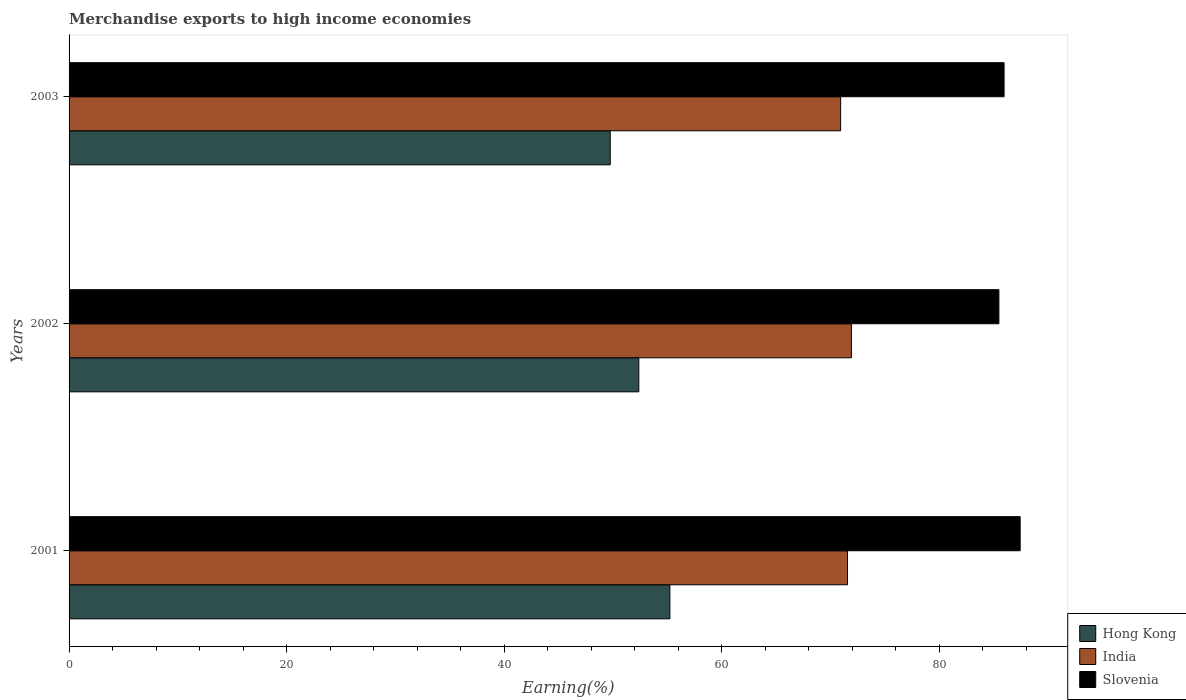Are the number of bars per tick equal to the number of legend labels?
Keep it short and to the point. Yes. How many bars are there on the 2nd tick from the top?
Your response must be concise. 3. What is the percentage of amount earned from merchandise exports in Hong Kong in 2003?
Offer a very short reply. 49.76. Across all years, what is the maximum percentage of amount earned from merchandise exports in India?
Keep it short and to the point. 71.94. Across all years, what is the minimum percentage of amount earned from merchandise exports in India?
Your answer should be compact. 70.95. In which year was the percentage of amount earned from merchandise exports in Slovenia minimum?
Keep it short and to the point. 2002. What is the total percentage of amount earned from merchandise exports in Hong Kong in the graph?
Give a very brief answer. 157.39. What is the difference between the percentage of amount earned from merchandise exports in Hong Kong in 2001 and that in 2003?
Offer a terse response. 5.49. What is the difference between the percentage of amount earned from merchandise exports in Slovenia in 2001 and the percentage of amount earned from merchandise exports in India in 2003?
Your answer should be compact. 16.51. What is the average percentage of amount earned from merchandise exports in Hong Kong per year?
Provide a short and direct response. 52.46. In the year 2002, what is the difference between the percentage of amount earned from merchandise exports in Slovenia and percentage of amount earned from merchandise exports in India?
Offer a terse response. 13.56. In how many years, is the percentage of amount earned from merchandise exports in Hong Kong greater than 72 %?
Give a very brief answer. 0. What is the ratio of the percentage of amount earned from merchandise exports in Slovenia in 2001 to that in 2003?
Your answer should be compact. 1.02. Is the percentage of amount earned from merchandise exports in Hong Kong in 2001 less than that in 2002?
Offer a terse response. No. What is the difference between the highest and the second highest percentage of amount earned from merchandise exports in India?
Offer a very short reply. 0.36. What is the difference between the highest and the lowest percentage of amount earned from merchandise exports in Hong Kong?
Provide a short and direct response. 5.49. Is the sum of the percentage of amount earned from merchandise exports in Hong Kong in 2001 and 2003 greater than the maximum percentage of amount earned from merchandise exports in Slovenia across all years?
Provide a short and direct response. Yes. What does the 2nd bar from the top in 2002 represents?
Give a very brief answer. India. What does the 3rd bar from the bottom in 2003 represents?
Your answer should be very brief. Slovenia. How many bars are there?
Keep it short and to the point. 9. How many years are there in the graph?
Offer a terse response. 3. What is the difference between two consecutive major ticks on the X-axis?
Offer a terse response. 20. Are the values on the major ticks of X-axis written in scientific E-notation?
Keep it short and to the point. No. Does the graph contain any zero values?
Provide a short and direct response. No. How many legend labels are there?
Provide a short and direct response. 3. What is the title of the graph?
Offer a very short reply. Merchandise exports to high income economies. What is the label or title of the X-axis?
Keep it short and to the point. Earning(%). What is the label or title of the Y-axis?
Offer a terse response. Years. What is the Earning(%) in Hong Kong in 2001?
Give a very brief answer. 55.25. What is the Earning(%) of India in 2001?
Your answer should be very brief. 71.58. What is the Earning(%) in Slovenia in 2001?
Offer a terse response. 87.45. What is the Earning(%) of Hong Kong in 2002?
Ensure brevity in your answer.  52.39. What is the Earning(%) in India in 2002?
Ensure brevity in your answer.  71.94. What is the Earning(%) of Slovenia in 2002?
Keep it short and to the point. 85.5. What is the Earning(%) of Hong Kong in 2003?
Your answer should be compact. 49.76. What is the Earning(%) of India in 2003?
Keep it short and to the point. 70.95. What is the Earning(%) in Slovenia in 2003?
Make the answer very short. 85.98. Across all years, what is the maximum Earning(%) in Hong Kong?
Provide a succinct answer. 55.25. Across all years, what is the maximum Earning(%) of India?
Ensure brevity in your answer.  71.94. Across all years, what is the maximum Earning(%) of Slovenia?
Offer a terse response. 87.45. Across all years, what is the minimum Earning(%) in Hong Kong?
Keep it short and to the point. 49.76. Across all years, what is the minimum Earning(%) of India?
Ensure brevity in your answer.  70.95. Across all years, what is the minimum Earning(%) in Slovenia?
Offer a terse response. 85.5. What is the total Earning(%) in Hong Kong in the graph?
Ensure brevity in your answer.  157.39. What is the total Earning(%) of India in the graph?
Keep it short and to the point. 214.46. What is the total Earning(%) of Slovenia in the graph?
Ensure brevity in your answer.  258.93. What is the difference between the Earning(%) in Hong Kong in 2001 and that in 2002?
Your answer should be compact. 2.86. What is the difference between the Earning(%) of India in 2001 and that in 2002?
Provide a succinct answer. -0.36. What is the difference between the Earning(%) in Slovenia in 2001 and that in 2002?
Your answer should be very brief. 1.95. What is the difference between the Earning(%) in Hong Kong in 2001 and that in 2003?
Provide a succinct answer. 5.49. What is the difference between the Earning(%) of India in 2001 and that in 2003?
Offer a terse response. 0.63. What is the difference between the Earning(%) of Slovenia in 2001 and that in 2003?
Ensure brevity in your answer.  1.48. What is the difference between the Earning(%) of Hong Kong in 2002 and that in 2003?
Keep it short and to the point. 2.63. What is the difference between the Earning(%) in India in 2002 and that in 2003?
Provide a short and direct response. 0.99. What is the difference between the Earning(%) in Slovenia in 2002 and that in 2003?
Keep it short and to the point. -0.48. What is the difference between the Earning(%) in Hong Kong in 2001 and the Earning(%) in India in 2002?
Your answer should be compact. -16.69. What is the difference between the Earning(%) of Hong Kong in 2001 and the Earning(%) of Slovenia in 2002?
Ensure brevity in your answer.  -30.25. What is the difference between the Earning(%) in India in 2001 and the Earning(%) in Slovenia in 2002?
Ensure brevity in your answer.  -13.92. What is the difference between the Earning(%) in Hong Kong in 2001 and the Earning(%) in India in 2003?
Your response must be concise. -15.7. What is the difference between the Earning(%) of Hong Kong in 2001 and the Earning(%) of Slovenia in 2003?
Keep it short and to the point. -30.73. What is the difference between the Earning(%) in India in 2001 and the Earning(%) in Slovenia in 2003?
Your answer should be compact. -14.4. What is the difference between the Earning(%) in Hong Kong in 2002 and the Earning(%) in India in 2003?
Your response must be concise. -18.56. What is the difference between the Earning(%) of Hong Kong in 2002 and the Earning(%) of Slovenia in 2003?
Your response must be concise. -33.59. What is the difference between the Earning(%) of India in 2002 and the Earning(%) of Slovenia in 2003?
Offer a terse response. -14.04. What is the average Earning(%) in Hong Kong per year?
Offer a terse response. 52.46. What is the average Earning(%) in India per year?
Ensure brevity in your answer.  71.49. What is the average Earning(%) of Slovenia per year?
Ensure brevity in your answer.  86.31. In the year 2001, what is the difference between the Earning(%) of Hong Kong and Earning(%) of India?
Make the answer very short. -16.33. In the year 2001, what is the difference between the Earning(%) in Hong Kong and Earning(%) in Slovenia?
Your answer should be very brief. -32.21. In the year 2001, what is the difference between the Earning(%) in India and Earning(%) in Slovenia?
Your response must be concise. -15.87. In the year 2002, what is the difference between the Earning(%) of Hong Kong and Earning(%) of India?
Keep it short and to the point. -19.55. In the year 2002, what is the difference between the Earning(%) of Hong Kong and Earning(%) of Slovenia?
Offer a terse response. -33.11. In the year 2002, what is the difference between the Earning(%) of India and Earning(%) of Slovenia?
Your answer should be very brief. -13.56. In the year 2003, what is the difference between the Earning(%) of Hong Kong and Earning(%) of India?
Provide a short and direct response. -21.19. In the year 2003, what is the difference between the Earning(%) of Hong Kong and Earning(%) of Slovenia?
Your answer should be very brief. -36.22. In the year 2003, what is the difference between the Earning(%) of India and Earning(%) of Slovenia?
Offer a terse response. -15.03. What is the ratio of the Earning(%) in Hong Kong in 2001 to that in 2002?
Offer a very short reply. 1.05. What is the ratio of the Earning(%) in India in 2001 to that in 2002?
Your response must be concise. 0.99. What is the ratio of the Earning(%) in Slovenia in 2001 to that in 2002?
Provide a short and direct response. 1.02. What is the ratio of the Earning(%) of Hong Kong in 2001 to that in 2003?
Make the answer very short. 1.11. What is the ratio of the Earning(%) in India in 2001 to that in 2003?
Your answer should be very brief. 1.01. What is the ratio of the Earning(%) of Slovenia in 2001 to that in 2003?
Your answer should be compact. 1.02. What is the ratio of the Earning(%) of Hong Kong in 2002 to that in 2003?
Provide a succinct answer. 1.05. What is the difference between the highest and the second highest Earning(%) in Hong Kong?
Provide a succinct answer. 2.86. What is the difference between the highest and the second highest Earning(%) of India?
Provide a short and direct response. 0.36. What is the difference between the highest and the second highest Earning(%) in Slovenia?
Your response must be concise. 1.48. What is the difference between the highest and the lowest Earning(%) of Hong Kong?
Provide a succinct answer. 5.49. What is the difference between the highest and the lowest Earning(%) of Slovenia?
Offer a very short reply. 1.95. 